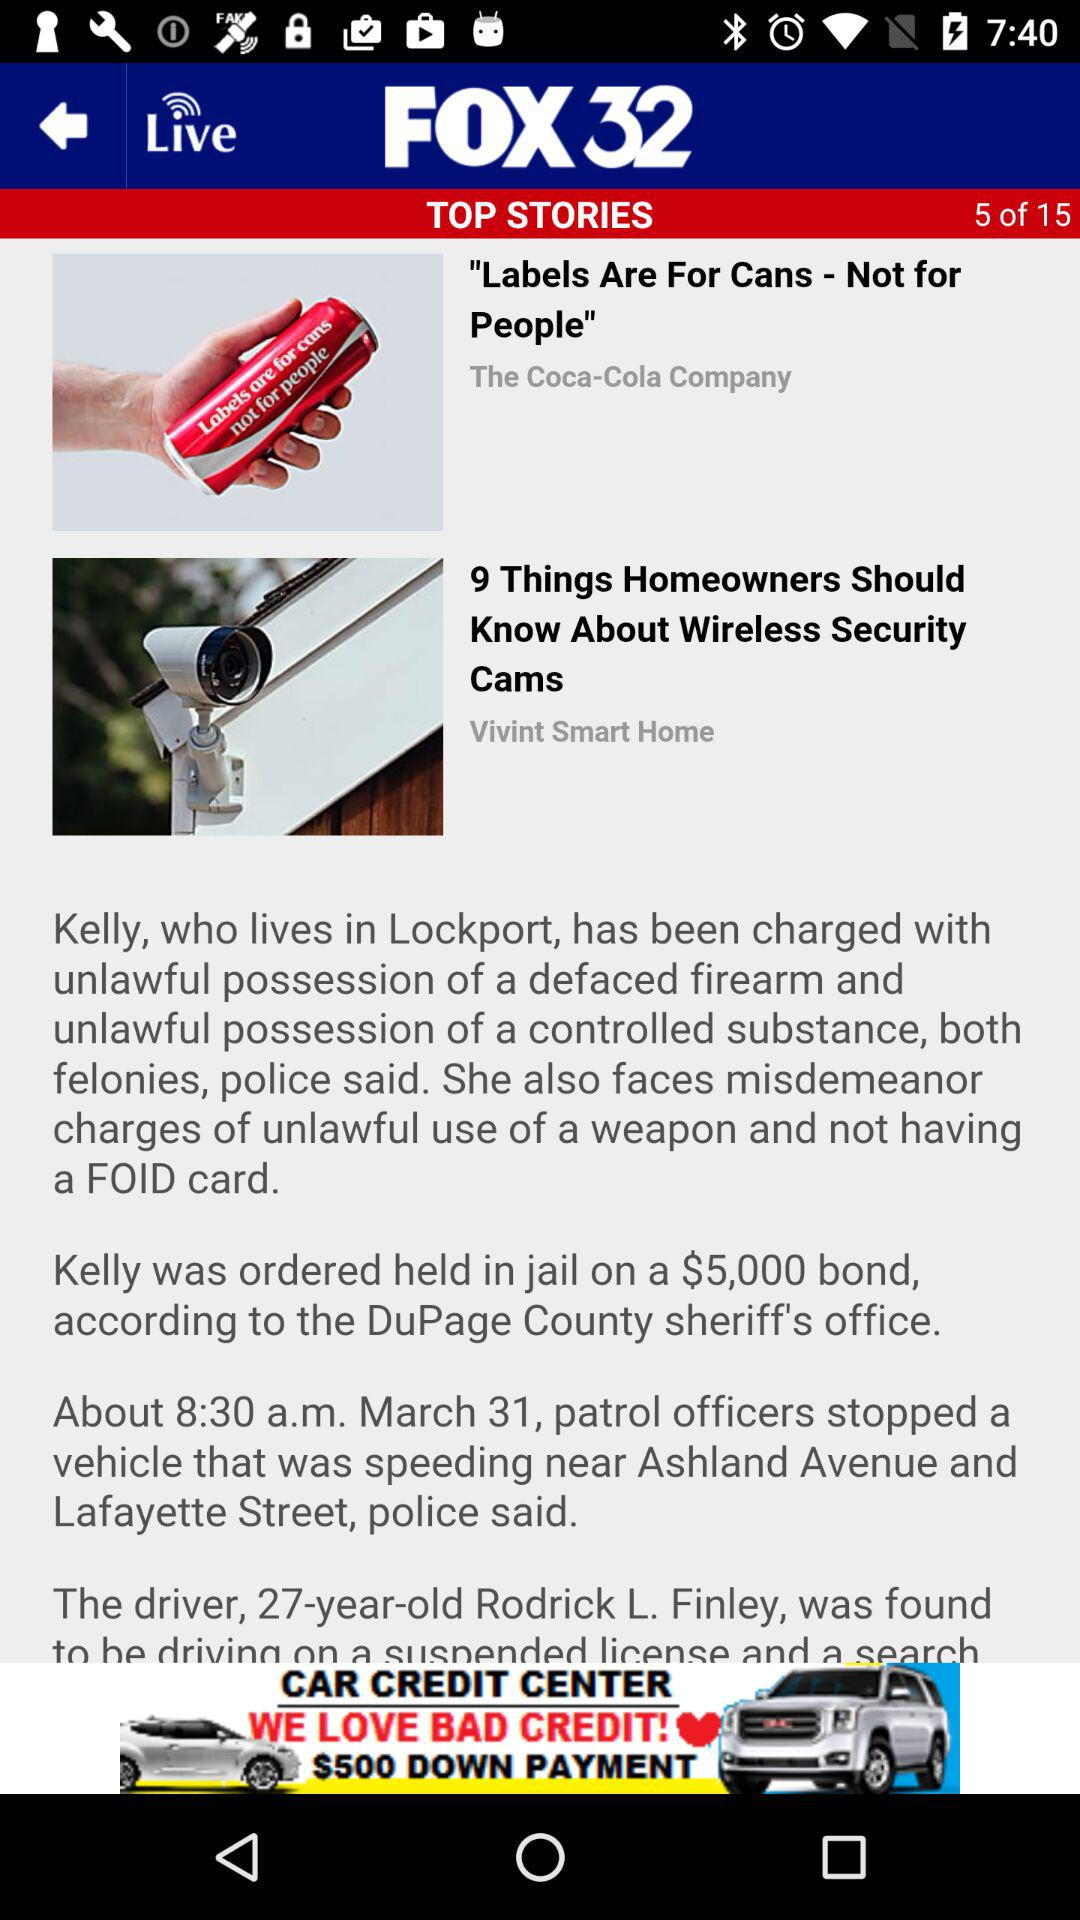What is the current top story number? We are currently on top story number five. 